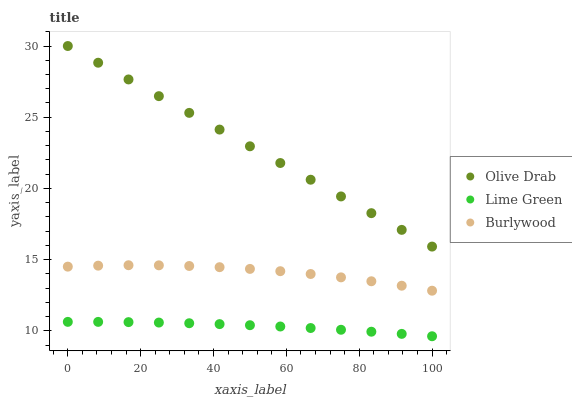Does Lime Green have the minimum area under the curve?
Answer yes or no. Yes. Does Olive Drab have the maximum area under the curve?
Answer yes or no. Yes. Does Olive Drab have the minimum area under the curve?
Answer yes or no. No. Does Lime Green have the maximum area under the curve?
Answer yes or no. No. Is Olive Drab the smoothest?
Answer yes or no. Yes. Is Burlywood the roughest?
Answer yes or no. Yes. Is Lime Green the smoothest?
Answer yes or no. No. Is Lime Green the roughest?
Answer yes or no. No. Does Lime Green have the lowest value?
Answer yes or no. Yes. Does Olive Drab have the lowest value?
Answer yes or no. No. Does Olive Drab have the highest value?
Answer yes or no. Yes. Does Lime Green have the highest value?
Answer yes or no. No. Is Burlywood less than Olive Drab?
Answer yes or no. Yes. Is Olive Drab greater than Lime Green?
Answer yes or no. Yes. Does Burlywood intersect Olive Drab?
Answer yes or no. No. 